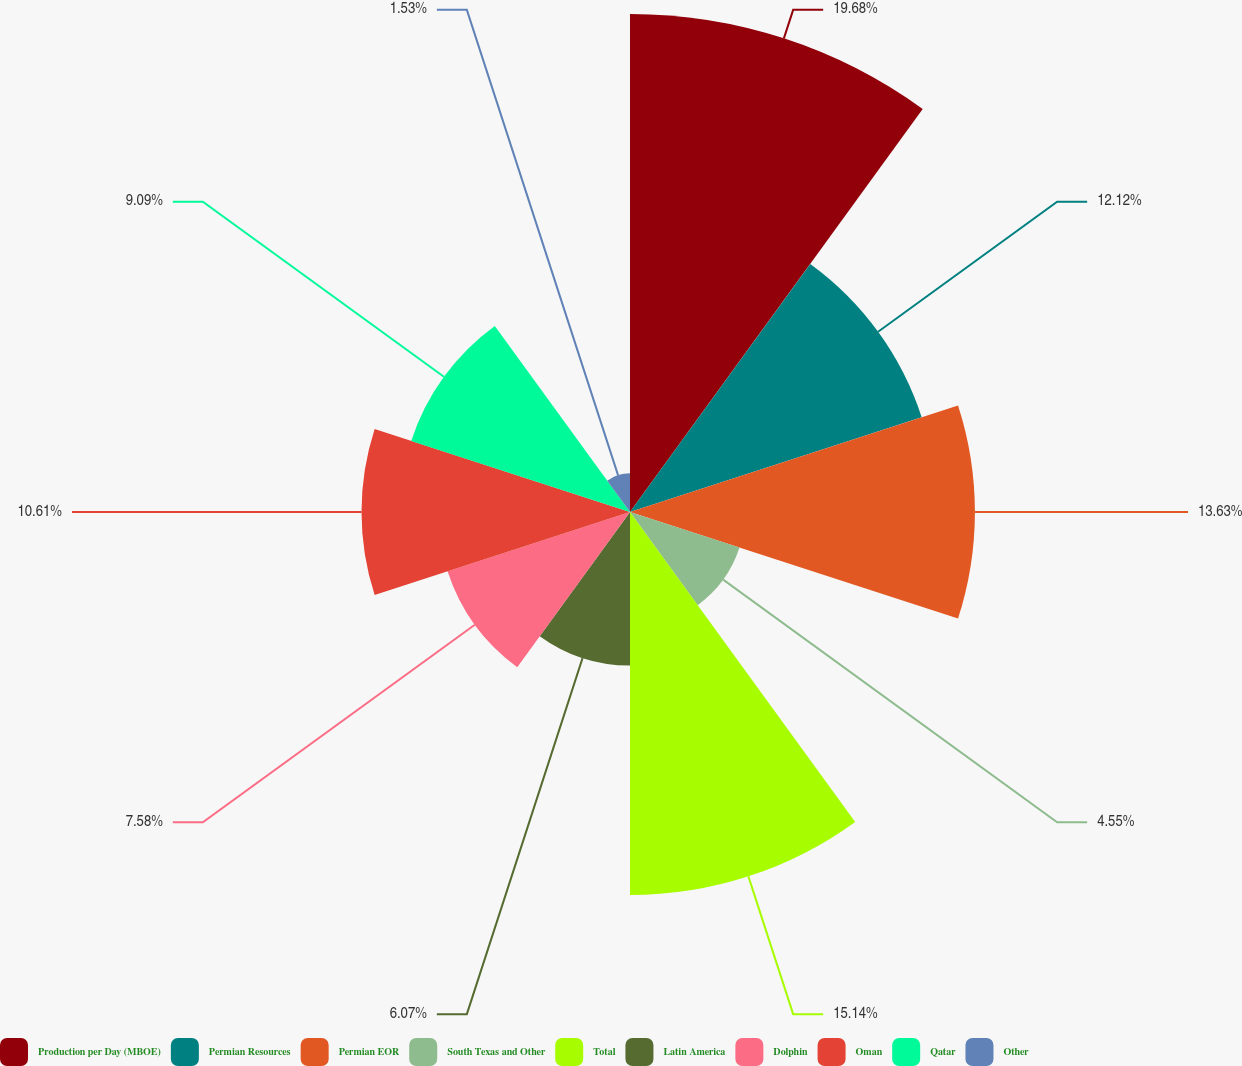Convert chart to OTSL. <chart><loc_0><loc_0><loc_500><loc_500><pie_chart><fcel>Production per Day (MBOE)<fcel>Permian Resources<fcel>Permian EOR<fcel>South Texas and Other<fcel>Total<fcel>Latin America<fcel>Dolphin<fcel>Oman<fcel>Qatar<fcel>Other<nl><fcel>19.68%<fcel>12.12%<fcel>13.63%<fcel>4.55%<fcel>15.14%<fcel>6.07%<fcel>7.58%<fcel>10.61%<fcel>9.09%<fcel>1.53%<nl></chart> 